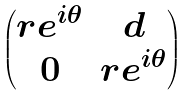Convert formula to latex. <formula><loc_0><loc_0><loc_500><loc_500>\begin{pmatrix} r e ^ { i \theta } & d \\ 0 & r e ^ { i \theta } \end{pmatrix}</formula> 